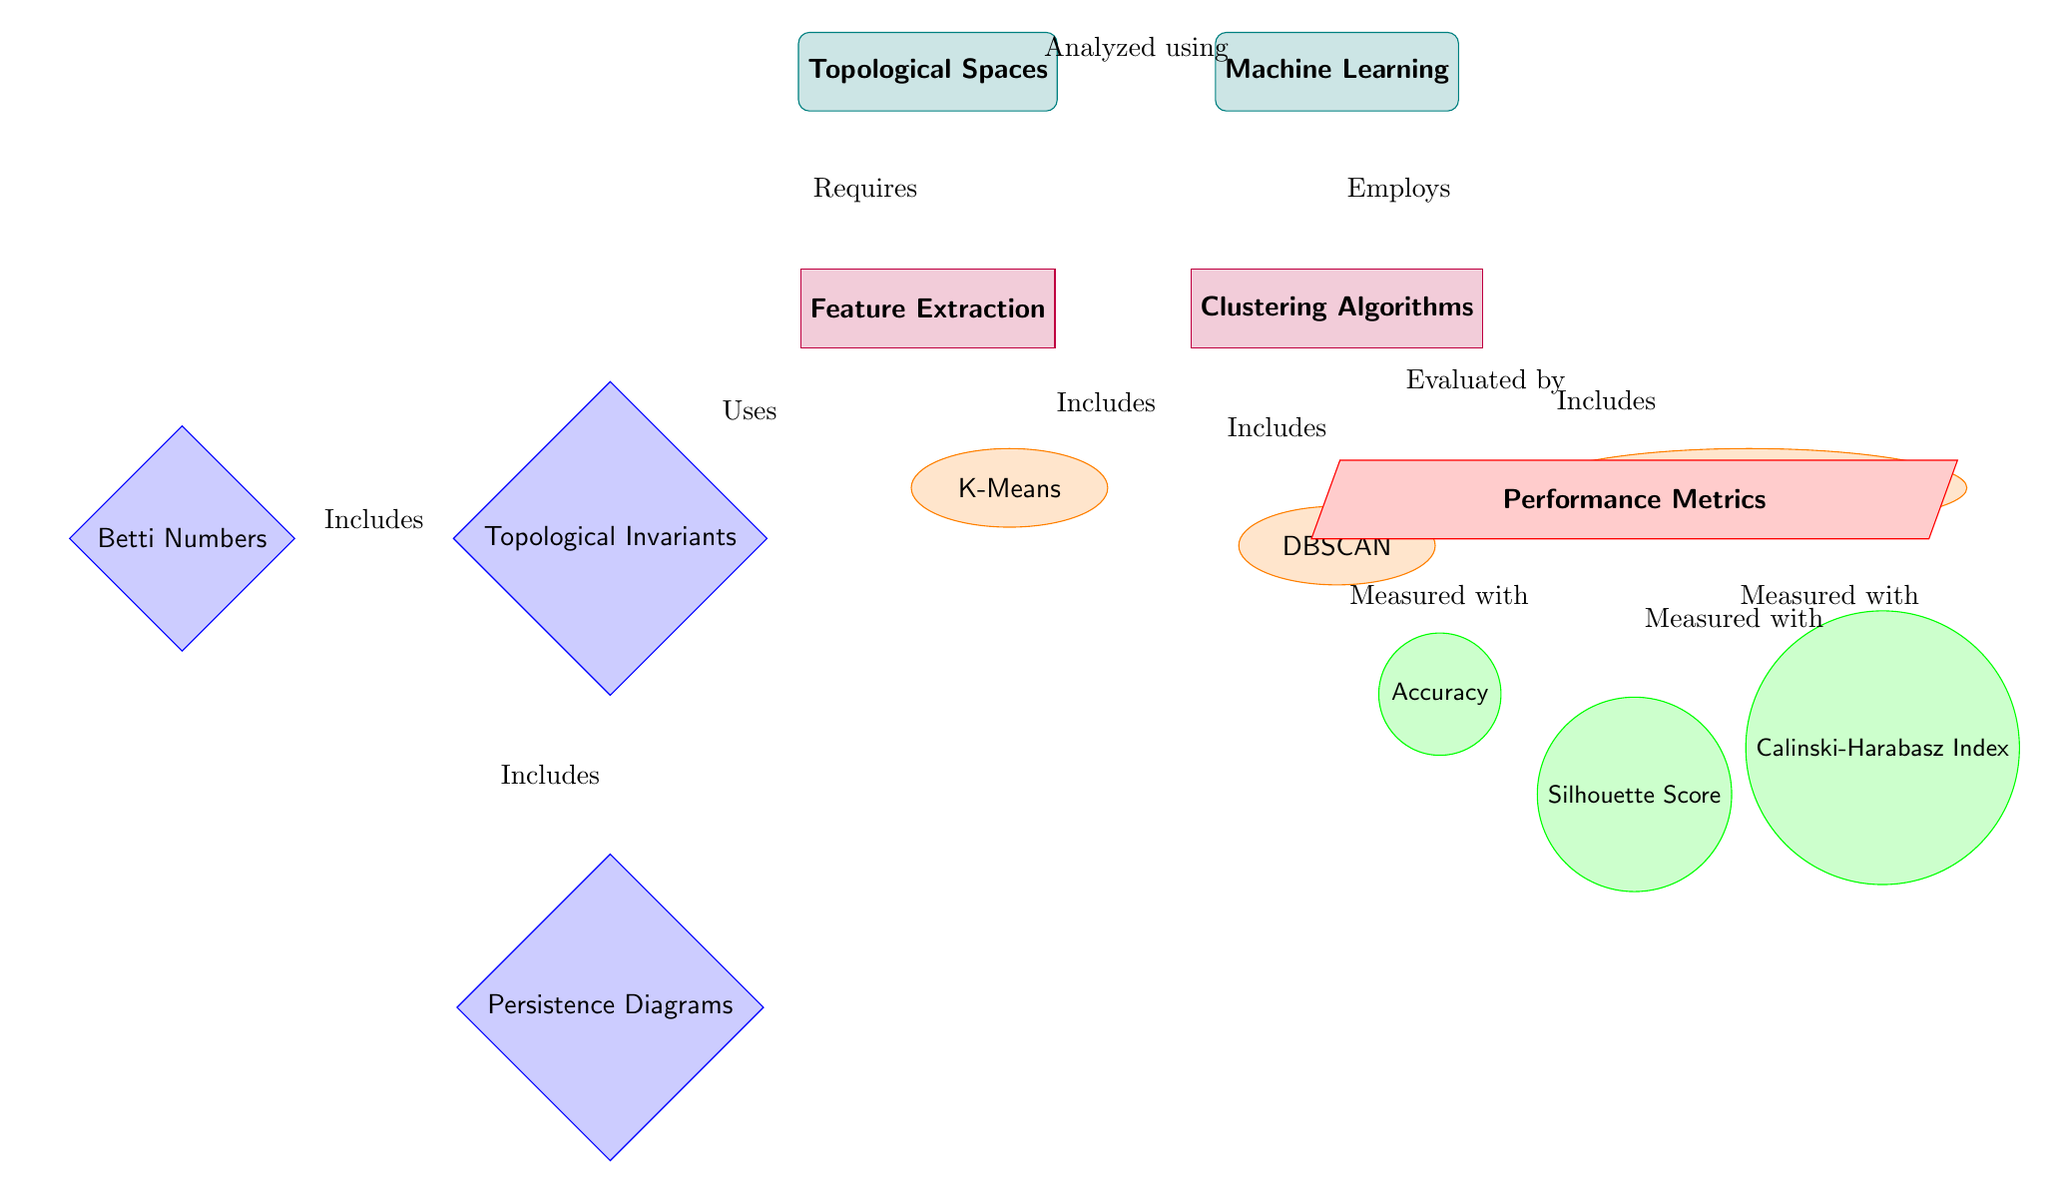What are the clustering algorithms mentioned in the diagram? The diagram lists three clustering algorithms under the "Clustering Algorithms" process: K-Means, DBSCAN, and Agglomerative Clustering.
Answer: K-Means, DBSCAN, Agglomerative Clustering What are the performance metrics used to evaluate the clustering algorithms? The diagram specifies three performance metrics used for evaluation: Accuracy, Silhouette Score, and Calinski-Harabasz Index.
Answer: Accuracy, Silhouette Score, Calinski-Harabasz Index How many types of topological invariants are included in the diagram? There are two types of topological invariants listed: Betti Numbers and Persistence Diagrams.
Answer: Two Which process requires feature extraction to analyze topological spaces? The arrow pointing from "Topological Spaces" to "Feature Extraction" indicates that feature extraction is necessary to analyze topological spaces.
Answer: Feature Extraction Which clustering method is positioned directly below the clustering algorithms in the diagram? The clustering algorithms order from top to bottom denotes that K-Means is positioned directly below them.
Answer: K-Means Which performance metric is related to the measurement of cluster cohesion and separation? Silhouette Score measures how similar an object is to its own cluster compared to other clusters, indicating cluster cohesion and separation.
Answer: Silhouette Score How are the clustering algorithms evaluated, according to the diagram? The clustering algorithms are evaluated by performance metrics, as shown by the arrow pointing to "Performance Metrics" from "Clustering Algorithms."
Answer: Evaluated by Performance Metrics What is the relationship between topological spaces and machine learning? The arrow indicates that topological spaces are analyzed using machine learning, showing their interrelation in the context of the diagram.
Answer: Analyzed using Machine Learning What does the diagram indicate is necessary for clustering algorithms to analyze topological spaces? The diagram indicates that feature extraction is required for clustering algorithms to effectively analyze topological spaces.
Answer: Feature Extraction 